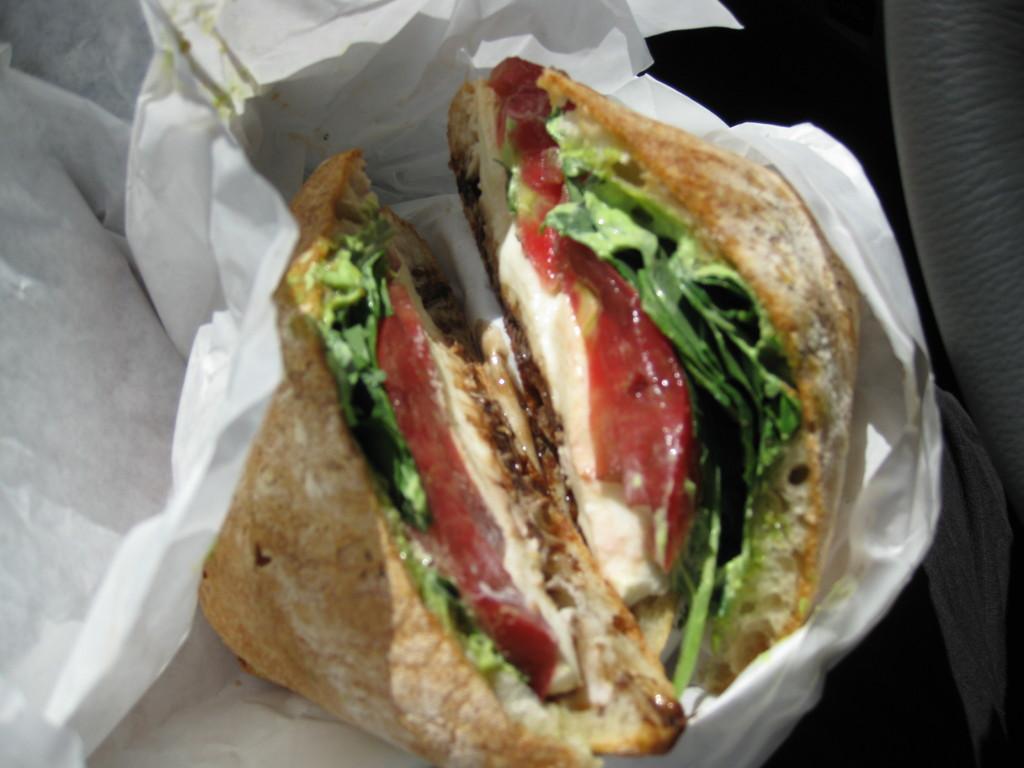In one or two sentences, can you explain what this image depicts? In the center of the picture we can see a food item seems to be a burger wrapped in a paper and we can see some other objects. 